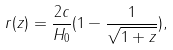<formula> <loc_0><loc_0><loc_500><loc_500>r ( z ) = \frac { 2 c } { H _ { 0 } } ( 1 - \frac { 1 } { \sqrt { 1 + z } } ) ,</formula> 